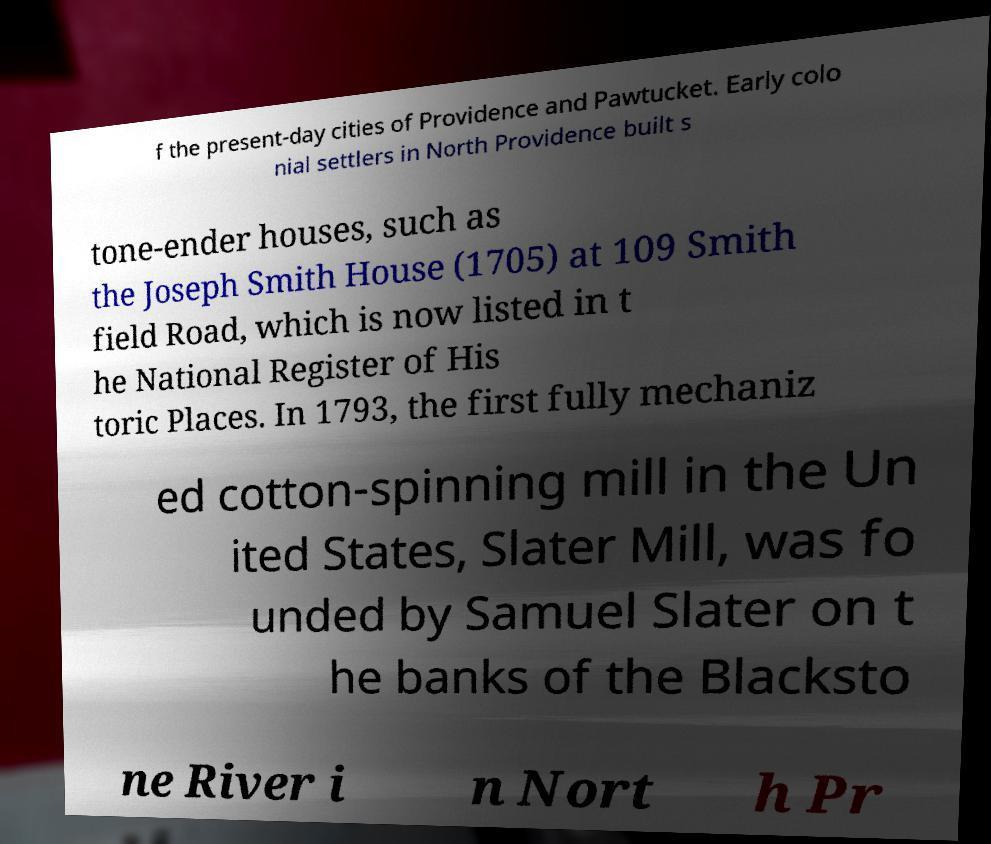What messages or text are displayed in this image? I need them in a readable, typed format. f the present-day cities of Providence and Pawtucket. Early colo nial settlers in North Providence built s tone-ender houses, such as the Joseph Smith House (1705) at 109 Smith field Road, which is now listed in t he National Register of His toric Places. In 1793, the first fully mechaniz ed cotton-spinning mill in the Un ited States, Slater Mill, was fo unded by Samuel Slater on t he banks of the Blacksto ne River i n Nort h Pr 